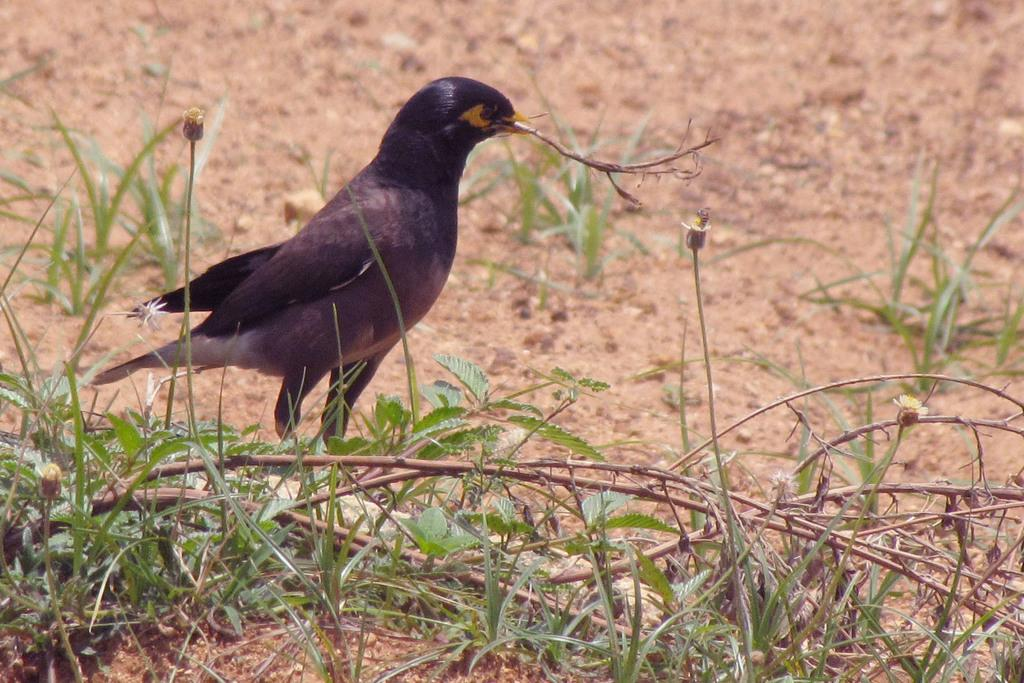What type of animal can be seen in the image? There is a bird in the image. What is the ground covered with in the image? There is grass on the ground in the image. What type of silk is the judge wearing in the image? There is no judge or silk present in the image; it features a bird and grass. 